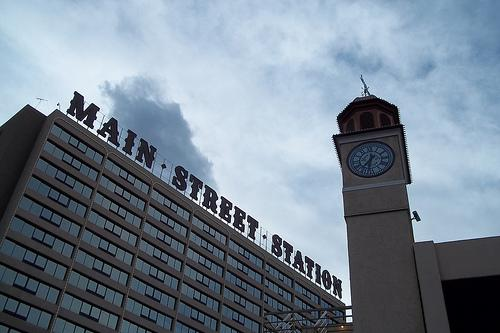What is the main purpose of the prominent structure in the image and what is displayed on it? The Main Street Station building serves as a train station, displaying a large clock with Roman numerals and a sign that reads "Main Street Station." Identify any interesting design elements on the Main Street Station building. Some interesting design elements include old-fashioned font on the sign, a statue on top of the building, and a weather vane on the tower. Write a description of the view from one of the higher points of the building. From the lookout tower and walk-out balcony, the view of the surrounding area is captivating and expansive. Mention the most prominent structure in the image and describe its features. The Main Street Station building with many windows and several floors, stands tall, housing a large clock with Roman numerals and a weather vane on top of it. Write a brief overview of the main elements and the overall atmosphere of the image. The image shows a stormy sky over the Main Street Station building having many windows and several floors, featuring a large clock with Roman numerals, a weather vane, and a security camera. Describe some other objects and structures surrounding the Main Street Station building. There is a building with a statue next to the Main Street Station, as well as a handrail near the stairs and a light on a wall. Give a brief description of the weather in the picture and an object in the sky. The sky has a cloudy, blue and gray appearance, suggesting an approaching storm with some visible smoke in the sky. Describe any security measures visible on the building. There is a security camera mounted on the side of the tower to keep an eye on the area around the building. What time do the clock hands display and describe the appearance of the clock? The clock shows a little past 7:30 and has Roman numerals on its blue face, outlined in black. List some details about the windows of the Main Street Station building. The building has several narrow windows, arranged in rows, each with six sections. The weather vane on the tower is shaped like a fish, right? There's no mention of the weather vane being in the shape of a fish; thus, this question introduces a misleading attribute. Notice how the main street station sign uses sleek, modern font. This instruction contradicts the information given, which describes the main street station font as old fashioned. Find the large purple banner hanging from the building. No mention of a purple banner has been provided in the image information, so this instruction introduces a misleading attribute. Is the clock tower completely red instead of blue? The instructions mention the clock is blue, so asking if the clock tower is red creates a misleading instruction with contradictory information. The statue on top of the building appears to be a lion, wouldn't you say? This question introduces a misleading attribute since there is no mention of the statue being a lion in the provided information. Observe the absence of any windows on the building. This instruction is misleading as the given information clearly states that the building has many windows. The number of sections in each window is only two, correct? This question contradicts the given information that each window has six sections, making it a misleading instruction. The sky seems to be clear and sunny, agree? This instruction contradicts the provided information that the sky looks like a storm is coming and is a cloudy blue sky. The clock says it is midnight, doesn't it? This question contradicts the information provided that states 6:35 or a little past 7:30 as clock times, making it a misleading instruction. Are there any flowers growing on the balcony's railing? No mention of flowers on the railing has been provided in the image information, so this question introduces a misleading attribute. 